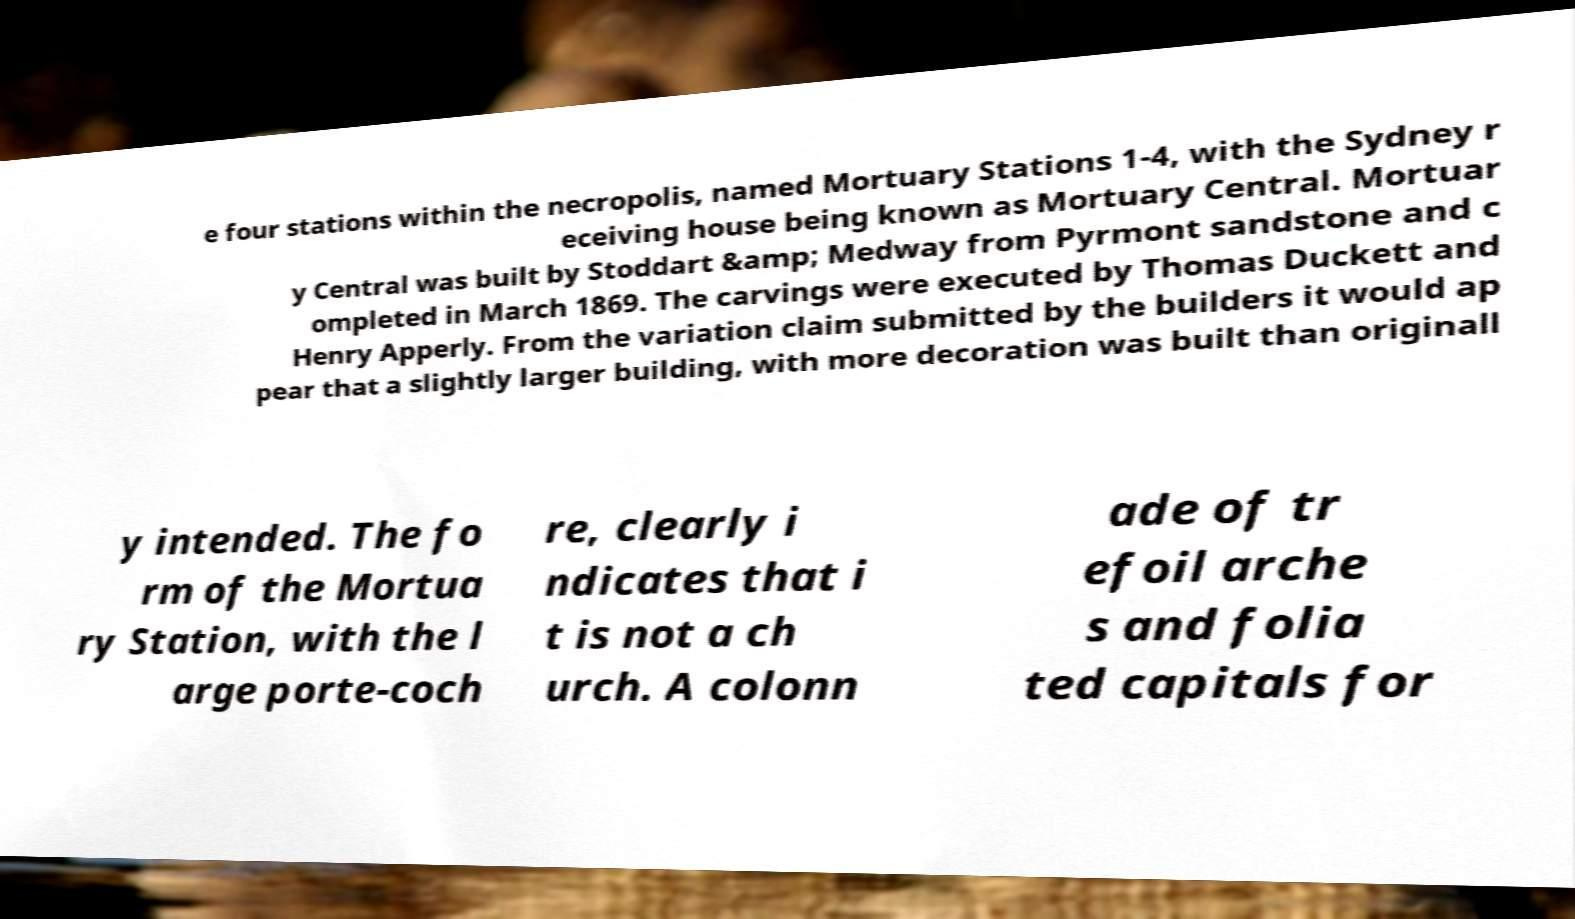What messages or text are displayed in this image? I need them in a readable, typed format. e four stations within the necropolis, named Mortuary Stations 1-4, with the Sydney r eceiving house being known as Mortuary Central. Mortuar y Central was built by Stoddart &amp; Medway from Pyrmont sandstone and c ompleted in March 1869. The carvings were executed by Thomas Duckett and Henry Apperly. From the variation claim submitted by the builders it would ap pear that a slightly larger building, with more decoration was built than originall y intended. The fo rm of the Mortua ry Station, with the l arge porte-coch re, clearly i ndicates that i t is not a ch urch. A colonn ade of tr efoil arche s and folia ted capitals for 